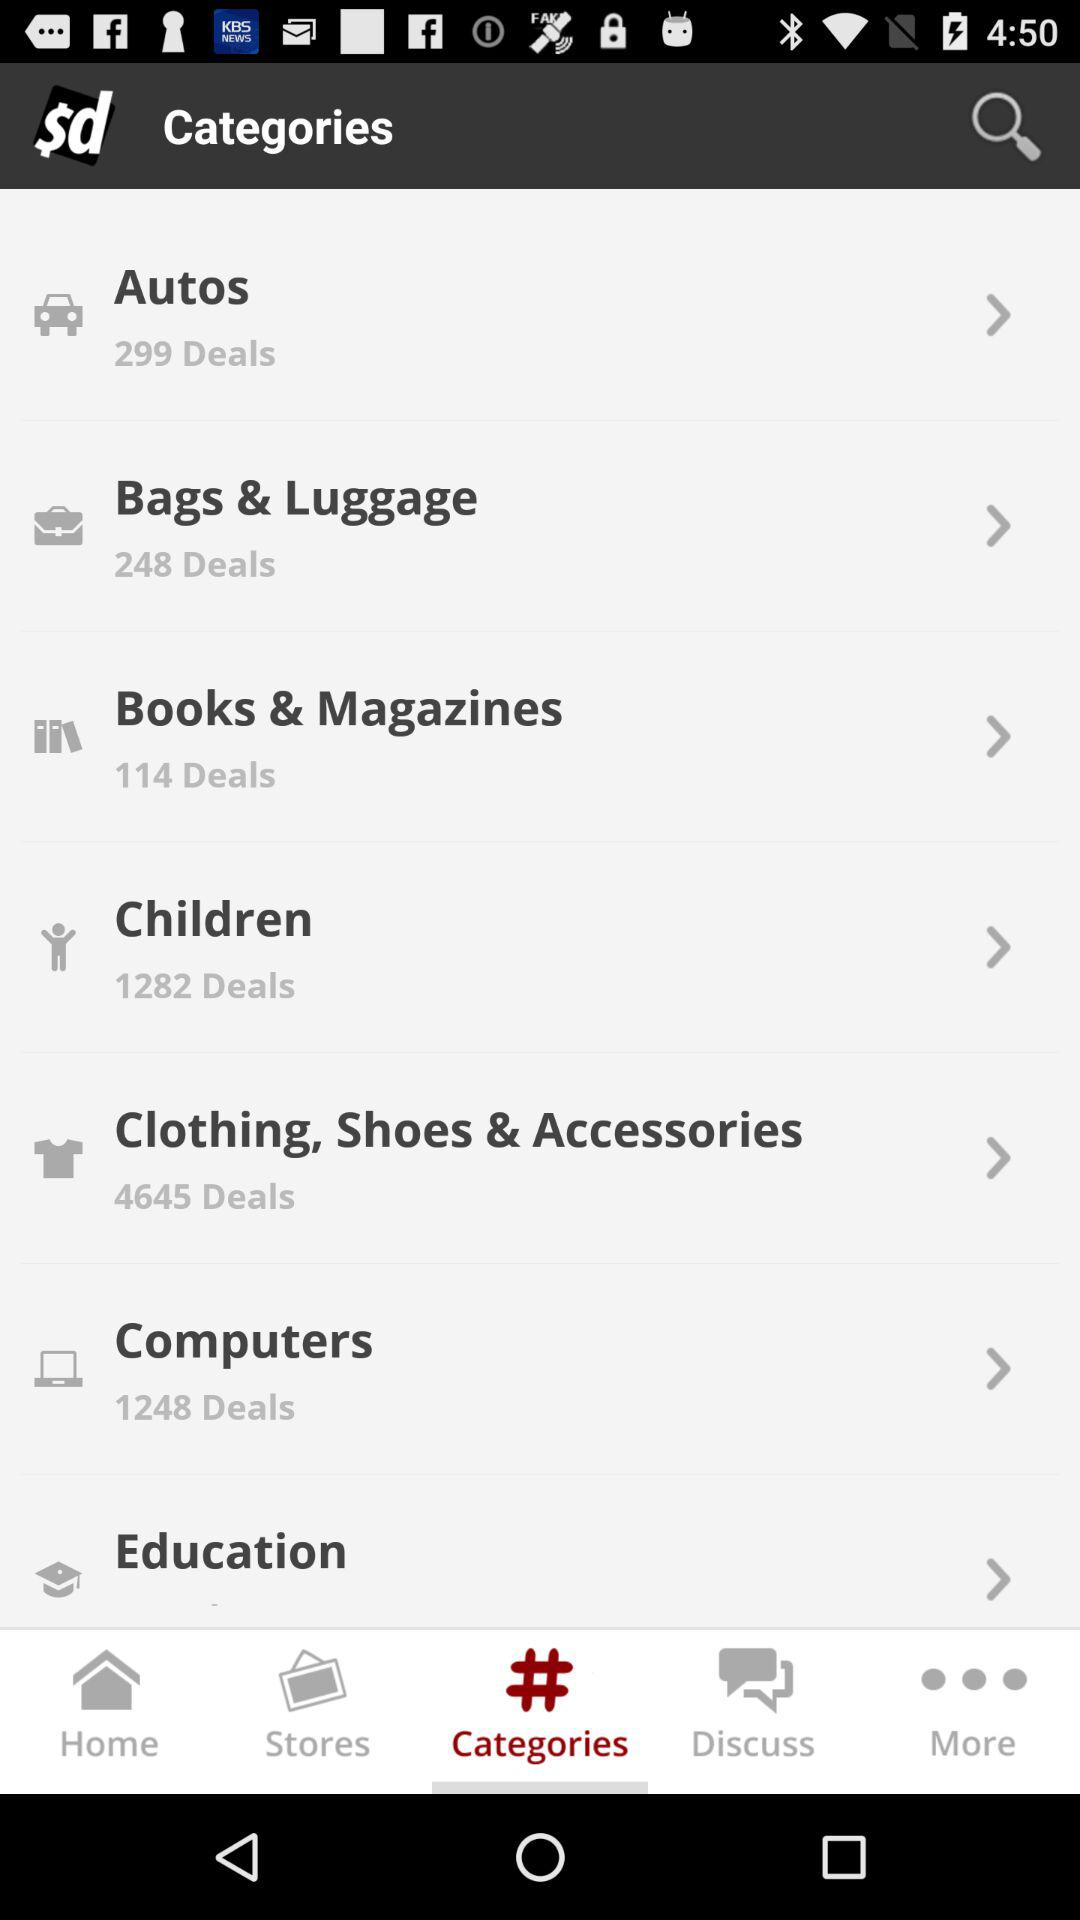How many deals are in "Books & Magazines"? There are 114 deals. 